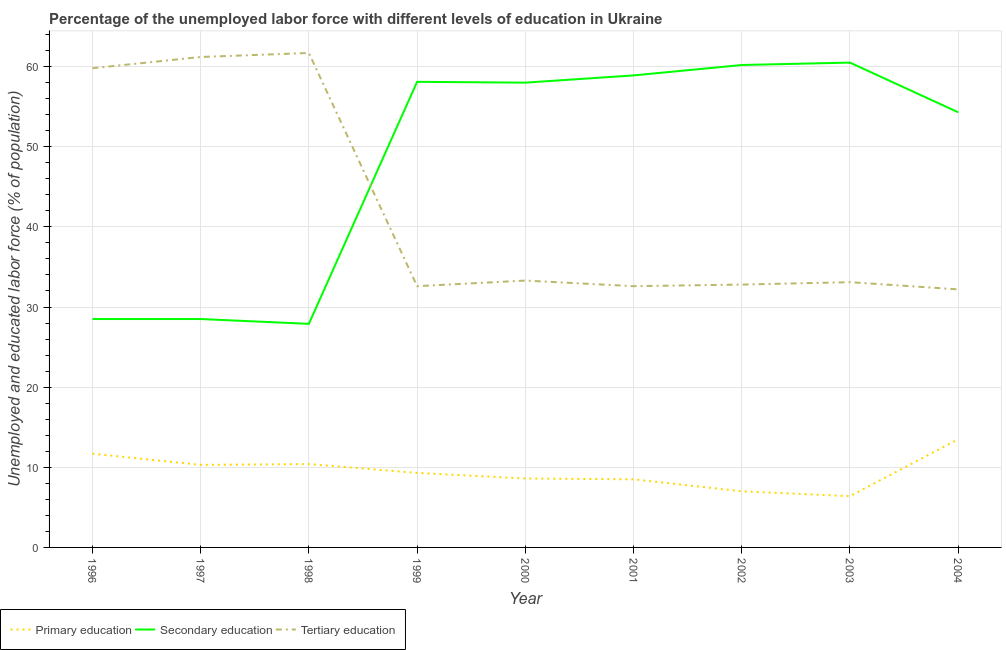Does the line corresponding to percentage of labor force who received secondary education intersect with the line corresponding to percentage of labor force who received tertiary education?
Offer a very short reply. Yes. Is the number of lines equal to the number of legend labels?
Your answer should be very brief. Yes. What is the percentage of labor force who received secondary education in 2003?
Your answer should be compact. 60.5. Across all years, what is the maximum percentage of labor force who received secondary education?
Provide a succinct answer. 60.5. Across all years, what is the minimum percentage of labor force who received secondary education?
Your answer should be very brief. 27.9. In which year was the percentage of labor force who received tertiary education maximum?
Provide a short and direct response. 1998. What is the total percentage of labor force who received secondary education in the graph?
Offer a very short reply. 434.9. What is the difference between the percentage of labor force who received primary education in 1999 and that in 2003?
Give a very brief answer. 2.9. What is the difference between the percentage of labor force who received primary education in 1998 and the percentage of labor force who received tertiary education in 2000?
Your answer should be compact. -22.9. What is the average percentage of labor force who received tertiary education per year?
Keep it short and to the point. 42.14. In the year 2004, what is the difference between the percentage of labor force who received primary education and percentage of labor force who received secondary education?
Your answer should be compact. -40.8. In how many years, is the percentage of labor force who received primary education greater than 26 %?
Make the answer very short. 0. What is the ratio of the percentage of labor force who received secondary education in 1999 to that in 2001?
Make the answer very short. 0.99. Is the percentage of labor force who received primary education in 2001 less than that in 2002?
Your answer should be very brief. No. What is the difference between the highest and the second highest percentage of labor force who received primary education?
Your answer should be compact. 1.8. What is the difference between the highest and the lowest percentage of labor force who received tertiary education?
Offer a very short reply. 29.5. In how many years, is the percentage of labor force who received primary education greater than the average percentage of labor force who received primary education taken over all years?
Provide a short and direct response. 4. Is the sum of the percentage of labor force who received primary education in 1998 and 2004 greater than the maximum percentage of labor force who received secondary education across all years?
Provide a succinct answer. No. Does the percentage of labor force who received tertiary education monotonically increase over the years?
Provide a short and direct response. No. Is the percentage of labor force who received secondary education strictly greater than the percentage of labor force who received tertiary education over the years?
Provide a succinct answer. No. What is the difference between two consecutive major ticks on the Y-axis?
Keep it short and to the point. 10. Are the values on the major ticks of Y-axis written in scientific E-notation?
Keep it short and to the point. No. Does the graph contain any zero values?
Your answer should be very brief. No. Does the graph contain grids?
Make the answer very short. Yes. What is the title of the graph?
Ensure brevity in your answer.  Percentage of the unemployed labor force with different levels of education in Ukraine. Does "Transport equipments" appear as one of the legend labels in the graph?
Keep it short and to the point. No. What is the label or title of the X-axis?
Provide a short and direct response. Year. What is the label or title of the Y-axis?
Your answer should be very brief. Unemployed and educated labor force (% of population). What is the Unemployed and educated labor force (% of population) in Primary education in 1996?
Your answer should be very brief. 11.7. What is the Unemployed and educated labor force (% of population) in Tertiary education in 1996?
Give a very brief answer. 59.8. What is the Unemployed and educated labor force (% of population) in Primary education in 1997?
Provide a succinct answer. 10.3. What is the Unemployed and educated labor force (% of population) of Secondary education in 1997?
Provide a succinct answer. 28.5. What is the Unemployed and educated labor force (% of population) in Tertiary education in 1997?
Make the answer very short. 61.2. What is the Unemployed and educated labor force (% of population) in Primary education in 1998?
Keep it short and to the point. 10.4. What is the Unemployed and educated labor force (% of population) in Secondary education in 1998?
Provide a short and direct response. 27.9. What is the Unemployed and educated labor force (% of population) in Tertiary education in 1998?
Provide a succinct answer. 61.7. What is the Unemployed and educated labor force (% of population) of Primary education in 1999?
Ensure brevity in your answer.  9.3. What is the Unemployed and educated labor force (% of population) of Secondary education in 1999?
Your answer should be very brief. 58.1. What is the Unemployed and educated labor force (% of population) in Tertiary education in 1999?
Provide a succinct answer. 32.6. What is the Unemployed and educated labor force (% of population) in Primary education in 2000?
Your response must be concise. 8.6. What is the Unemployed and educated labor force (% of population) of Secondary education in 2000?
Your answer should be very brief. 58. What is the Unemployed and educated labor force (% of population) in Tertiary education in 2000?
Provide a succinct answer. 33.3. What is the Unemployed and educated labor force (% of population) in Primary education in 2001?
Offer a very short reply. 8.5. What is the Unemployed and educated labor force (% of population) of Secondary education in 2001?
Offer a terse response. 58.9. What is the Unemployed and educated labor force (% of population) in Tertiary education in 2001?
Keep it short and to the point. 32.6. What is the Unemployed and educated labor force (% of population) in Primary education in 2002?
Make the answer very short. 7. What is the Unemployed and educated labor force (% of population) in Secondary education in 2002?
Ensure brevity in your answer.  60.2. What is the Unemployed and educated labor force (% of population) of Tertiary education in 2002?
Your answer should be compact. 32.8. What is the Unemployed and educated labor force (% of population) of Primary education in 2003?
Make the answer very short. 6.4. What is the Unemployed and educated labor force (% of population) of Secondary education in 2003?
Provide a short and direct response. 60.5. What is the Unemployed and educated labor force (% of population) in Tertiary education in 2003?
Your response must be concise. 33.1. What is the Unemployed and educated labor force (% of population) of Primary education in 2004?
Give a very brief answer. 13.5. What is the Unemployed and educated labor force (% of population) in Secondary education in 2004?
Keep it short and to the point. 54.3. What is the Unemployed and educated labor force (% of population) of Tertiary education in 2004?
Your answer should be compact. 32.2. Across all years, what is the maximum Unemployed and educated labor force (% of population) of Primary education?
Your answer should be compact. 13.5. Across all years, what is the maximum Unemployed and educated labor force (% of population) in Secondary education?
Ensure brevity in your answer.  60.5. Across all years, what is the maximum Unemployed and educated labor force (% of population) of Tertiary education?
Offer a very short reply. 61.7. Across all years, what is the minimum Unemployed and educated labor force (% of population) of Primary education?
Provide a succinct answer. 6.4. Across all years, what is the minimum Unemployed and educated labor force (% of population) of Secondary education?
Provide a short and direct response. 27.9. Across all years, what is the minimum Unemployed and educated labor force (% of population) in Tertiary education?
Your answer should be very brief. 32.2. What is the total Unemployed and educated labor force (% of population) in Primary education in the graph?
Give a very brief answer. 85.7. What is the total Unemployed and educated labor force (% of population) in Secondary education in the graph?
Keep it short and to the point. 434.9. What is the total Unemployed and educated labor force (% of population) of Tertiary education in the graph?
Give a very brief answer. 379.3. What is the difference between the Unemployed and educated labor force (% of population) in Primary education in 1996 and that in 1997?
Your response must be concise. 1.4. What is the difference between the Unemployed and educated labor force (% of population) in Tertiary education in 1996 and that in 1997?
Provide a succinct answer. -1.4. What is the difference between the Unemployed and educated labor force (% of population) in Tertiary education in 1996 and that in 1998?
Your answer should be compact. -1.9. What is the difference between the Unemployed and educated labor force (% of population) in Primary education in 1996 and that in 1999?
Offer a terse response. 2.4. What is the difference between the Unemployed and educated labor force (% of population) in Secondary education in 1996 and that in 1999?
Make the answer very short. -29.6. What is the difference between the Unemployed and educated labor force (% of population) of Tertiary education in 1996 and that in 1999?
Ensure brevity in your answer.  27.2. What is the difference between the Unemployed and educated labor force (% of population) of Primary education in 1996 and that in 2000?
Provide a short and direct response. 3.1. What is the difference between the Unemployed and educated labor force (% of population) in Secondary education in 1996 and that in 2000?
Offer a terse response. -29.5. What is the difference between the Unemployed and educated labor force (% of population) of Tertiary education in 1996 and that in 2000?
Provide a short and direct response. 26.5. What is the difference between the Unemployed and educated labor force (% of population) of Primary education in 1996 and that in 2001?
Your answer should be compact. 3.2. What is the difference between the Unemployed and educated labor force (% of population) in Secondary education in 1996 and that in 2001?
Make the answer very short. -30.4. What is the difference between the Unemployed and educated labor force (% of population) in Tertiary education in 1996 and that in 2001?
Provide a short and direct response. 27.2. What is the difference between the Unemployed and educated labor force (% of population) of Primary education in 1996 and that in 2002?
Your answer should be very brief. 4.7. What is the difference between the Unemployed and educated labor force (% of population) of Secondary education in 1996 and that in 2002?
Provide a succinct answer. -31.7. What is the difference between the Unemployed and educated labor force (% of population) in Tertiary education in 1996 and that in 2002?
Give a very brief answer. 27. What is the difference between the Unemployed and educated labor force (% of population) in Secondary education in 1996 and that in 2003?
Keep it short and to the point. -32. What is the difference between the Unemployed and educated labor force (% of population) of Tertiary education in 1996 and that in 2003?
Ensure brevity in your answer.  26.7. What is the difference between the Unemployed and educated labor force (% of population) of Primary education in 1996 and that in 2004?
Ensure brevity in your answer.  -1.8. What is the difference between the Unemployed and educated labor force (% of population) of Secondary education in 1996 and that in 2004?
Your response must be concise. -25.8. What is the difference between the Unemployed and educated labor force (% of population) of Tertiary education in 1996 and that in 2004?
Ensure brevity in your answer.  27.6. What is the difference between the Unemployed and educated labor force (% of population) of Tertiary education in 1997 and that in 1998?
Offer a terse response. -0.5. What is the difference between the Unemployed and educated labor force (% of population) of Secondary education in 1997 and that in 1999?
Offer a very short reply. -29.6. What is the difference between the Unemployed and educated labor force (% of population) of Tertiary education in 1997 and that in 1999?
Your answer should be very brief. 28.6. What is the difference between the Unemployed and educated labor force (% of population) in Secondary education in 1997 and that in 2000?
Your answer should be very brief. -29.5. What is the difference between the Unemployed and educated labor force (% of population) of Tertiary education in 1997 and that in 2000?
Make the answer very short. 27.9. What is the difference between the Unemployed and educated labor force (% of population) of Primary education in 1997 and that in 2001?
Provide a short and direct response. 1.8. What is the difference between the Unemployed and educated labor force (% of population) of Secondary education in 1997 and that in 2001?
Offer a very short reply. -30.4. What is the difference between the Unemployed and educated labor force (% of population) of Tertiary education in 1997 and that in 2001?
Offer a very short reply. 28.6. What is the difference between the Unemployed and educated labor force (% of population) in Secondary education in 1997 and that in 2002?
Ensure brevity in your answer.  -31.7. What is the difference between the Unemployed and educated labor force (% of population) in Tertiary education in 1997 and that in 2002?
Your answer should be very brief. 28.4. What is the difference between the Unemployed and educated labor force (% of population) in Secondary education in 1997 and that in 2003?
Offer a terse response. -32. What is the difference between the Unemployed and educated labor force (% of population) of Tertiary education in 1997 and that in 2003?
Your response must be concise. 28.1. What is the difference between the Unemployed and educated labor force (% of population) in Secondary education in 1997 and that in 2004?
Provide a short and direct response. -25.8. What is the difference between the Unemployed and educated labor force (% of population) of Secondary education in 1998 and that in 1999?
Make the answer very short. -30.2. What is the difference between the Unemployed and educated labor force (% of population) of Tertiary education in 1998 and that in 1999?
Offer a very short reply. 29.1. What is the difference between the Unemployed and educated labor force (% of population) in Secondary education in 1998 and that in 2000?
Keep it short and to the point. -30.1. What is the difference between the Unemployed and educated labor force (% of population) in Tertiary education in 1998 and that in 2000?
Provide a succinct answer. 28.4. What is the difference between the Unemployed and educated labor force (% of population) of Primary education in 1998 and that in 2001?
Your answer should be very brief. 1.9. What is the difference between the Unemployed and educated labor force (% of population) in Secondary education in 1998 and that in 2001?
Provide a succinct answer. -31. What is the difference between the Unemployed and educated labor force (% of population) in Tertiary education in 1998 and that in 2001?
Your answer should be compact. 29.1. What is the difference between the Unemployed and educated labor force (% of population) in Secondary education in 1998 and that in 2002?
Offer a very short reply. -32.3. What is the difference between the Unemployed and educated labor force (% of population) in Tertiary education in 1998 and that in 2002?
Provide a succinct answer. 28.9. What is the difference between the Unemployed and educated labor force (% of population) of Primary education in 1998 and that in 2003?
Ensure brevity in your answer.  4. What is the difference between the Unemployed and educated labor force (% of population) of Secondary education in 1998 and that in 2003?
Your response must be concise. -32.6. What is the difference between the Unemployed and educated labor force (% of population) of Tertiary education in 1998 and that in 2003?
Make the answer very short. 28.6. What is the difference between the Unemployed and educated labor force (% of population) of Primary education in 1998 and that in 2004?
Provide a short and direct response. -3.1. What is the difference between the Unemployed and educated labor force (% of population) of Secondary education in 1998 and that in 2004?
Give a very brief answer. -26.4. What is the difference between the Unemployed and educated labor force (% of population) of Tertiary education in 1998 and that in 2004?
Provide a succinct answer. 29.5. What is the difference between the Unemployed and educated labor force (% of population) in Secondary education in 1999 and that in 2000?
Keep it short and to the point. 0.1. What is the difference between the Unemployed and educated labor force (% of population) of Tertiary education in 1999 and that in 2000?
Your answer should be very brief. -0.7. What is the difference between the Unemployed and educated labor force (% of population) in Primary education in 1999 and that in 2001?
Offer a very short reply. 0.8. What is the difference between the Unemployed and educated labor force (% of population) in Primary education in 1999 and that in 2002?
Your answer should be compact. 2.3. What is the difference between the Unemployed and educated labor force (% of population) in Secondary education in 1999 and that in 2002?
Provide a succinct answer. -2.1. What is the difference between the Unemployed and educated labor force (% of population) in Primary education in 1999 and that in 2003?
Make the answer very short. 2.9. What is the difference between the Unemployed and educated labor force (% of population) of Tertiary education in 1999 and that in 2003?
Keep it short and to the point. -0.5. What is the difference between the Unemployed and educated labor force (% of population) in Primary education in 2000 and that in 2001?
Provide a succinct answer. 0.1. What is the difference between the Unemployed and educated labor force (% of population) of Tertiary education in 2000 and that in 2001?
Offer a very short reply. 0.7. What is the difference between the Unemployed and educated labor force (% of population) in Primary education in 2000 and that in 2002?
Offer a very short reply. 1.6. What is the difference between the Unemployed and educated labor force (% of population) in Primary education in 2000 and that in 2003?
Provide a short and direct response. 2.2. What is the difference between the Unemployed and educated labor force (% of population) in Secondary education in 2000 and that in 2003?
Give a very brief answer. -2.5. What is the difference between the Unemployed and educated labor force (% of population) of Primary education in 2000 and that in 2004?
Offer a terse response. -4.9. What is the difference between the Unemployed and educated labor force (% of population) in Secondary education in 2000 and that in 2004?
Your response must be concise. 3.7. What is the difference between the Unemployed and educated labor force (% of population) in Tertiary education in 2000 and that in 2004?
Your answer should be compact. 1.1. What is the difference between the Unemployed and educated labor force (% of population) of Primary education in 2001 and that in 2002?
Offer a very short reply. 1.5. What is the difference between the Unemployed and educated labor force (% of population) in Secondary education in 2001 and that in 2004?
Offer a very short reply. 4.6. What is the difference between the Unemployed and educated labor force (% of population) of Tertiary education in 2001 and that in 2004?
Provide a succinct answer. 0.4. What is the difference between the Unemployed and educated labor force (% of population) of Primary education in 2002 and that in 2003?
Keep it short and to the point. 0.6. What is the difference between the Unemployed and educated labor force (% of population) of Primary education in 2002 and that in 2004?
Keep it short and to the point. -6.5. What is the difference between the Unemployed and educated labor force (% of population) in Secondary education in 2002 and that in 2004?
Your answer should be very brief. 5.9. What is the difference between the Unemployed and educated labor force (% of population) of Tertiary education in 2002 and that in 2004?
Offer a terse response. 0.6. What is the difference between the Unemployed and educated labor force (% of population) of Tertiary education in 2003 and that in 2004?
Your answer should be very brief. 0.9. What is the difference between the Unemployed and educated labor force (% of population) of Primary education in 1996 and the Unemployed and educated labor force (% of population) of Secondary education in 1997?
Make the answer very short. -16.8. What is the difference between the Unemployed and educated labor force (% of population) in Primary education in 1996 and the Unemployed and educated labor force (% of population) in Tertiary education in 1997?
Offer a terse response. -49.5. What is the difference between the Unemployed and educated labor force (% of population) in Secondary education in 1996 and the Unemployed and educated labor force (% of population) in Tertiary education in 1997?
Your answer should be very brief. -32.7. What is the difference between the Unemployed and educated labor force (% of population) of Primary education in 1996 and the Unemployed and educated labor force (% of population) of Secondary education in 1998?
Ensure brevity in your answer.  -16.2. What is the difference between the Unemployed and educated labor force (% of population) of Secondary education in 1996 and the Unemployed and educated labor force (% of population) of Tertiary education in 1998?
Provide a short and direct response. -33.2. What is the difference between the Unemployed and educated labor force (% of population) of Primary education in 1996 and the Unemployed and educated labor force (% of population) of Secondary education in 1999?
Provide a succinct answer. -46.4. What is the difference between the Unemployed and educated labor force (% of population) in Primary education in 1996 and the Unemployed and educated labor force (% of population) in Tertiary education in 1999?
Ensure brevity in your answer.  -20.9. What is the difference between the Unemployed and educated labor force (% of population) in Primary education in 1996 and the Unemployed and educated labor force (% of population) in Secondary education in 2000?
Ensure brevity in your answer.  -46.3. What is the difference between the Unemployed and educated labor force (% of population) in Primary education in 1996 and the Unemployed and educated labor force (% of population) in Tertiary education in 2000?
Your response must be concise. -21.6. What is the difference between the Unemployed and educated labor force (% of population) of Primary education in 1996 and the Unemployed and educated labor force (% of population) of Secondary education in 2001?
Give a very brief answer. -47.2. What is the difference between the Unemployed and educated labor force (% of population) of Primary education in 1996 and the Unemployed and educated labor force (% of population) of Tertiary education in 2001?
Provide a succinct answer. -20.9. What is the difference between the Unemployed and educated labor force (% of population) of Secondary education in 1996 and the Unemployed and educated labor force (% of population) of Tertiary education in 2001?
Provide a short and direct response. -4.1. What is the difference between the Unemployed and educated labor force (% of population) of Primary education in 1996 and the Unemployed and educated labor force (% of population) of Secondary education in 2002?
Ensure brevity in your answer.  -48.5. What is the difference between the Unemployed and educated labor force (% of population) of Primary education in 1996 and the Unemployed and educated labor force (% of population) of Tertiary education in 2002?
Make the answer very short. -21.1. What is the difference between the Unemployed and educated labor force (% of population) of Secondary education in 1996 and the Unemployed and educated labor force (% of population) of Tertiary education in 2002?
Ensure brevity in your answer.  -4.3. What is the difference between the Unemployed and educated labor force (% of population) of Primary education in 1996 and the Unemployed and educated labor force (% of population) of Secondary education in 2003?
Offer a very short reply. -48.8. What is the difference between the Unemployed and educated labor force (% of population) in Primary education in 1996 and the Unemployed and educated labor force (% of population) in Tertiary education in 2003?
Keep it short and to the point. -21.4. What is the difference between the Unemployed and educated labor force (% of population) of Secondary education in 1996 and the Unemployed and educated labor force (% of population) of Tertiary education in 2003?
Provide a short and direct response. -4.6. What is the difference between the Unemployed and educated labor force (% of population) in Primary education in 1996 and the Unemployed and educated labor force (% of population) in Secondary education in 2004?
Provide a succinct answer. -42.6. What is the difference between the Unemployed and educated labor force (% of population) in Primary education in 1996 and the Unemployed and educated labor force (% of population) in Tertiary education in 2004?
Offer a very short reply. -20.5. What is the difference between the Unemployed and educated labor force (% of population) of Secondary education in 1996 and the Unemployed and educated labor force (% of population) of Tertiary education in 2004?
Provide a succinct answer. -3.7. What is the difference between the Unemployed and educated labor force (% of population) of Primary education in 1997 and the Unemployed and educated labor force (% of population) of Secondary education in 1998?
Offer a very short reply. -17.6. What is the difference between the Unemployed and educated labor force (% of population) of Primary education in 1997 and the Unemployed and educated labor force (% of population) of Tertiary education in 1998?
Provide a succinct answer. -51.4. What is the difference between the Unemployed and educated labor force (% of population) of Secondary education in 1997 and the Unemployed and educated labor force (% of population) of Tertiary education in 1998?
Offer a terse response. -33.2. What is the difference between the Unemployed and educated labor force (% of population) of Primary education in 1997 and the Unemployed and educated labor force (% of population) of Secondary education in 1999?
Provide a short and direct response. -47.8. What is the difference between the Unemployed and educated labor force (% of population) of Primary education in 1997 and the Unemployed and educated labor force (% of population) of Tertiary education in 1999?
Make the answer very short. -22.3. What is the difference between the Unemployed and educated labor force (% of population) of Primary education in 1997 and the Unemployed and educated labor force (% of population) of Secondary education in 2000?
Ensure brevity in your answer.  -47.7. What is the difference between the Unemployed and educated labor force (% of population) in Secondary education in 1997 and the Unemployed and educated labor force (% of population) in Tertiary education in 2000?
Provide a short and direct response. -4.8. What is the difference between the Unemployed and educated labor force (% of population) of Primary education in 1997 and the Unemployed and educated labor force (% of population) of Secondary education in 2001?
Offer a terse response. -48.6. What is the difference between the Unemployed and educated labor force (% of population) of Primary education in 1997 and the Unemployed and educated labor force (% of population) of Tertiary education in 2001?
Ensure brevity in your answer.  -22.3. What is the difference between the Unemployed and educated labor force (% of population) of Primary education in 1997 and the Unemployed and educated labor force (% of population) of Secondary education in 2002?
Offer a very short reply. -49.9. What is the difference between the Unemployed and educated labor force (% of population) in Primary education in 1997 and the Unemployed and educated labor force (% of population) in Tertiary education in 2002?
Your answer should be very brief. -22.5. What is the difference between the Unemployed and educated labor force (% of population) of Primary education in 1997 and the Unemployed and educated labor force (% of population) of Secondary education in 2003?
Offer a terse response. -50.2. What is the difference between the Unemployed and educated labor force (% of population) of Primary education in 1997 and the Unemployed and educated labor force (% of population) of Tertiary education in 2003?
Offer a terse response. -22.8. What is the difference between the Unemployed and educated labor force (% of population) of Secondary education in 1997 and the Unemployed and educated labor force (% of population) of Tertiary education in 2003?
Keep it short and to the point. -4.6. What is the difference between the Unemployed and educated labor force (% of population) of Primary education in 1997 and the Unemployed and educated labor force (% of population) of Secondary education in 2004?
Your response must be concise. -44. What is the difference between the Unemployed and educated labor force (% of population) of Primary education in 1997 and the Unemployed and educated labor force (% of population) of Tertiary education in 2004?
Give a very brief answer. -21.9. What is the difference between the Unemployed and educated labor force (% of population) in Secondary education in 1997 and the Unemployed and educated labor force (% of population) in Tertiary education in 2004?
Offer a very short reply. -3.7. What is the difference between the Unemployed and educated labor force (% of population) of Primary education in 1998 and the Unemployed and educated labor force (% of population) of Secondary education in 1999?
Keep it short and to the point. -47.7. What is the difference between the Unemployed and educated labor force (% of population) of Primary education in 1998 and the Unemployed and educated labor force (% of population) of Tertiary education in 1999?
Keep it short and to the point. -22.2. What is the difference between the Unemployed and educated labor force (% of population) in Secondary education in 1998 and the Unemployed and educated labor force (% of population) in Tertiary education in 1999?
Ensure brevity in your answer.  -4.7. What is the difference between the Unemployed and educated labor force (% of population) in Primary education in 1998 and the Unemployed and educated labor force (% of population) in Secondary education in 2000?
Offer a very short reply. -47.6. What is the difference between the Unemployed and educated labor force (% of population) in Primary education in 1998 and the Unemployed and educated labor force (% of population) in Tertiary education in 2000?
Give a very brief answer. -22.9. What is the difference between the Unemployed and educated labor force (% of population) in Primary education in 1998 and the Unemployed and educated labor force (% of population) in Secondary education in 2001?
Offer a terse response. -48.5. What is the difference between the Unemployed and educated labor force (% of population) in Primary education in 1998 and the Unemployed and educated labor force (% of population) in Tertiary education in 2001?
Your answer should be very brief. -22.2. What is the difference between the Unemployed and educated labor force (% of population) of Primary education in 1998 and the Unemployed and educated labor force (% of population) of Secondary education in 2002?
Provide a short and direct response. -49.8. What is the difference between the Unemployed and educated labor force (% of population) of Primary education in 1998 and the Unemployed and educated labor force (% of population) of Tertiary education in 2002?
Provide a short and direct response. -22.4. What is the difference between the Unemployed and educated labor force (% of population) in Secondary education in 1998 and the Unemployed and educated labor force (% of population) in Tertiary education in 2002?
Your answer should be compact. -4.9. What is the difference between the Unemployed and educated labor force (% of population) in Primary education in 1998 and the Unemployed and educated labor force (% of population) in Secondary education in 2003?
Provide a short and direct response. -50.1. What is the difference between the Unemployed and educated labor force (% of population) of Primary education in 1998 and the Unemployed and educated labor force (% of population) of Tertiary education in 2003?
Offer a very short reply. -22.7. What is the difference between the Unemployed and educated labor force (% of population) in Secondary education in 1998 and the Unemployed and educated labor force (% of population) in Tertiary education in 2003?
Offer a terse response. -5.2. What is the difference between the Unemployed and educated labor force (% of population) of Primary education in 1998 and the Unemployed and educated labor force (% of population) of Secondary education in 2004?
Make the answer very short. -43.9. What is the difference between the Unemployed and educated labor force (% of population) of Primary education in 1998 and the Unemployed and educated labor force (% of population) of Tertiary education in 2004?
Ensure brevity in your answer.  -21.8. What is the difference between the Unemployed and educated labor force (% of population) in Secondary education in 1998 and the Unemployed and educated labor force (% of population) in Tertiary education in 2004?
Your answer should be very brief. -4.3. What is the difference between the Unemployed and educated labor force (% of population) of Primary education in 1999 and the Unemployed and educated labor force (% of population) of Secondary education in 2000?
Your answer should be very brief. -48.7. What is the difference between the Unemployed and educated labor force (% of population) of Secondary education in 1999 and the Unemployed and educated labor force (% of population) of Tertiary education in 2000?
Give a very brief answer. 24.8. What is the difference between the Unemployed and educated labor force (% of population) of Primary education in 1999 and the Unemployed and educated labor force (% of population) of Secondary education in 2001?
Provide a succinct answer. -49.6. What is the difference between the Unemployed and educated labor force (% of population) of Primary education in 1999 and the Unemployed and educated labor force (% of population) of Tertiary education in 2001?
Offer a terse response. -23.3. What is the difference between the Unemployed and educated labor force (% of population) of Primary education in 1999 and the Unemployed and educated labor force (% of population) of Secondary education in 2002?
Your answer should be very brief. -50.9. What is the difference between the Unemployed and educated labor force (% of population) of Primary education in 1999 and the Unemployed and educated labor force (% of population) of Tertiary education in 2002?
Give a very brief answer. -23.5. What is the difference between the Unemployed and educated labor force (% of population) in Secondary education in 1999 and the Unemployed and educated labor force (% of population) in Tertiary education in 2002?
Your answer should be compact. 25.3. What is the difference between the Unemployed and educated labor force (% of population) of Primary education in 1999 and the Unemployed and educated labor force (% of population) of Secondary education in 2003?
Make the answer very short. -51.2. What is the difference between the Unemployed and educated labor force (% of population) in Primary education in 1999 and the Unemployed and educated labor force (% of population) in Tertiary education in 2003?
Provide a short and direct response. -23.8. What is the difference between the Unemployed and educated labor force (% of population) in Secondary education in 1999 and the Unemployed and educated labor force (% of population) in Tertiary education in 2003?
Ensure brevity in your answer.  25. What is the difference between the Unemployed and educated labor force (% of population) of Primary education in 1999 and the Unemployed and educated labor force (% of population) of Secondary education in 2004?
Ensure brevity in your answer.  -45. What is the difference between the Unemployed and educated labor force (% of population) of Primary education in 1999 and the Unemployed and educated labor force (% of population) of Tertiary education in 2004?
Offer a terse response. -22.9. What is the difference between the Unemployed and educated labor force (% of population) in Secondary education in 1999 and the Unemployed and educated labor force (% of population) in Tertiary education in 2004?
Ensure brevity in your answer.  25.9. What is the difference between the Unemployed and educated labor force (% of population) in Primary education in 2000 and the Unemployed and educated labor force (% of population) in Secondary education in 2001?
Make the answer very short. -50.3. What is the difference between the Unemployed and educated labor force (% of population) of Secondary education in 2000 and the Unemployed and educated labor force (% of population) of Tertiary education in 2001?
Give a very brief answer. 25.4. What is the difference between the Unemployed and educated labor force (% of population) of Primary education in 2000 and the Unemployed and educated labor force (% of population) of Secondary education in 2002?
Offer a very short reply. -51.6. What is the difference between the Unemployed and educated labor force (% of population) in Primary education in 2000 and the Unemployed and educated labor force (% of population) in Tertiary education in 2002?
Keep it short and to the point. -24.2. What is the difference between the Unemployed and educated labor force (% of population) in Secondary education in 2000 and the Unemployed and educated labor force (% of population) in Tertiary education in 2002?
Your answer should be very brief. 25.2. What is the difference between the Unemployed and educated labor force (% of population) of Primary education in 2000 and the Unemployed and educated labor force (% of population) of Secondary education in 2003?
Your response must be concise. -51.9. What is the difference between the Unemployed and educated labor force (% of population) of Primary education in 2000 and the Unemployed and educated labor force (% of population) of Tertiary education in 2003?
Make the answer very short. -24.5. What is the difference between the Unemployed and educated labor force (% of population) in Secondary education in 2000 and the Unemployed and educated labor force (% of population) in Tertiary education in 2003?
Offer a very short reply. 24.9. What is the difference between the Unemployed and educated labor force (% of population) in Primary education in 2000 and the Unemployed and educated labor force (% of population) in Secondary education in 2004?
Give a very brief answer. -45.7. What is the difference between the Unemployed and educated labor force (% of population) in Primary education in 2000 and the Unemployed and educated labor force (% of population) in Tertiary education in 2004?
Ensure brevity in your answer.  -23.6. What is the difference between the Unemployed and educated labor force (% of population) in Secondary education in 2000 and the Unemployed and educated labor force (% of population) in Tertiary education in 2004?
Make the answer very short. 25.8. What is the difference between the Unemployed and educated labor force (% of population) of Primary education in 2001 and the Unemployed and educated labor force (% of population) of Secondary education in 2002?
Offer a very short reply. -51.7. What is the difference between the Unemployed and educated labor force (% of population) of Primary education in 2001 and the Unemployed and educated labor force (% of population) of Tertiary education in 2002?
Give a very brief answer. -24.3. What is the difference between the Unemployed and educated labor force (% of population) of Secondary education in 2001 and the Unemployed and educated labor force (% of population) of Tertiary education in 2002?
Make the answer very short. 26.1. What is the difference between the Unemployed and educated labor force (% of population) of Primary education in 2001 and the Unemployed and educated labor force (% of population) of Secondary education in 2003?
Offer a very short reply. -52. What is the difference between the Unemployed and educated labor force (% of population) of Primary education in 2001 and the Unemployed and educated labor force (% of population) of Tertiary education in 2003?
Give a very brief answer. -24.6. What is the difference between the Unemployed and educated labor force (% of population) in Secondary education in 2001 and the Unemployed and educated labor force (% of population) in Tertiary education in 2003?
Your response must be concise. 25.8. What is the difference between the Unemployed and educated labor force (% of population) of Primary education in 2001 and the Unemployed and educated labor force (% of population) of Secondary education in 2004?
Give a very brief answer. -45.8. What is the difference between the Unemployed and educated labor force (% of population) in Primary education in 2001 and the Unemployed and educated labor force (% of population) in Tertiary education in 2004?
Provide a short and direct response. -23.7. What is the difference between the Unemployed and educated labor force (% of population) in Secondary education in 2001 and the Unemployed and educated labor force (% of population) in Tertiary education in 2004?
Ensure brevity in your answer.  26.7. What is the difference between the Unemployed and educated labor force (% of population) of Primary education in 2002 and the Unemployed and educated labor force (% of population) of Secondary education in 2003?
Keep it short and to the point. -53.5. What is the difference between the Unemployed and educated labor force (% of population) in Primary education in 2002 and the Unemployed and educated labor force (% of population) in Tertiary education in 2003?
Provide a succinct answer. -26.1. What is the difference between the Unemployed and educated labor force (% of population) in Secondary education in 2002 and the Unemployed and educated labor force (% of population) in Tertiary education in 2003?
Provide a succinct answer. 27.1. What is the difference between the Unemployed and educated labor force (% of population) in Primary education in 2002 and the Unemployed and educated labor force (% of population) in Secondary education in 2004?
Offer a terse response. -47.3. What is the difference between the Unemployed and educated labor force (% of population) of Primary education in 2002 and the Unemployed and educated labor force (% of population) of Tertiary education in 2004?
Your response must be concise. -25.2. What is the difference between the Unemployed and educated labor force (% of population) of Primary education in 2003 and the Unemployed and educated labor force (% of population) of Secondary education in 2004?
Offer a very short reply. -47.9. What is the difference between the Unemployed and educated labor force (% of population) of Primary education in 2003 and the Unemployed and educated labor force (% of population) of Tertiary education in 2004?
Provide a short and direct response. -25.8. What is the difference between the Unemployed and educated labor force (% of population) in Secondary education in 2003 and the Unemployed and educated labor force (% of population) in Tertiary education in 2004?
Your response must be concise. 28.3. What is the average Unemployed and educated labor force (% of population) in Primary education per year?
Offer a terse response. 9.52. What is the average Unemployed and educated labor force (% of population) in Secondary education per year?
Provide a succinct answer. 48.32. What is the average Unemployed and educated labor force (% of population) of Tertiary education per year?
Offer a very short reply. 42.14. In the year 1996, what is the difference between the Unemployed and educated labor force (% of population) in Primary education and Unemployed and educated labor force (% of population) in Secondary education?
Provide a succinct answer. -16.8. In the year 1996, what is the difference between the Unemployed and educated labor force (% of population) in Primary education and Unemployed and educated labor force (% of population) in Tertiary education?
Keep it short and to the point. -48.1. In the year 1996, what is the difference between the Unemployed and educated labor force (% of population) in Secondary education and Unemployed and educated labor force (% of population) in Tertiary education?
Keep it short and to the point. -31.3. In the year 1997, what is the difference between the Unemployed and educated labor force (% of population) in Primary education and Unemployed and educated labor force (% of population) in Secondary education?
Your response must be concise. -18.2. In the year 1997, what is the difference between the Unemployed and educated labor force (% of population) in Primary education and Unemployed and educated labor force (% of population) in Tertiary education?
Offer a very short reply. -50.9. In the year 1997, what is the difference between the Unemployed and educated labor force (% of population) in Secondary education and Unemployed and educated labor force (% of population) in Tertiary education?
Keep it short and to the point. -32.7. In the year 1998, what is the difference between the Unemployed and educated labor force (% of population) in Primary education and Unemployed and educated labor force (% of population) in Secondary education?
Your answer should be very brief. -17.5. In the year 1998, what is the difference between the Unemployed and educated labor force (% of population) of Primary education and Unemployed and educated labor force (% of population) of Tertiary education?
Offer a very short reply. -51.3. In the year 1998, what is the difference between the Unemployed and educated labor force (% of population) in Secondary education and Unemployed and educated labor force (% of population) in Tertiary education?
Offer a very short reply. -33.8. In the year 1999, what is the difference between the Unemployed and educated labor force (% of population) in Primary education and Unemployed and educated labor force (% of population) in Secondary education?
Make the answer very short. -48.8. In the year 1999, what is the difference between the Unemployed and educated labor force (% of population) of Primary education and Unemployed and educated labor force (% of population) of Tertiary education?
Your answer should be very brief. -23.3. In the year 2000, what is the difference between the Unemployed and educated labor force (% of population) in Primary education and Unemployed and educated labor force (% of population) in Secondary education?
Ensure brevity in your answer.  -49.4. In the year 2000, what is the difference between the Unemployed and educated labor force (% of population) in Primary education and Unemployed and educated labor force (% of population) in Tertiary education?
Your answer should be very brief. -24.7. In the year 2000, what is the difference between the Unemployed and educated labor force (% of population) of Secondary education and Unemployed and educated labor force (% of population) of Tertiary education?
Your answer should be very brief. 24.7. In the year 2001, what is the difference between the Unemployed and educated labor force (% of population) of Primary education and Unemployed and educated labor force (% of population) of Secondary education?
Make the answer very short. -50.4. In the year 2001, what is the difference between the Unemployed and educated labor force (% of population) of Primary education and Unemployed and educated labor force (% of population) of Tertiary education?
Make the answer very short. -24.1. In the year 2001, what is the difference between the Unemployed and educated labor force (% of population) of Secondary education and Unemployed and educated labor force (% of population) of Tertiary education?
Give a very brief answer. 26.3. In the year 2002, what is the difference between the Unemployed and educated labor force (% of population) of Primary education and Unemployed and educated labor force (% of population) of Secondary education?
Offer a terse response. -53.2. In the year 2002, what is the difference between the Unemployed and educated labor force (% of population) of Primary education and Unemployed and educated labor force (% of population) of Tertiary education?
Make the answer very short. -25.8. In the year 2002, what is the difference between the Unemployed and educated labor force (% of population) of Secondary education and Unemployed and educated labor force (% of population) of Tertiary education?
Your answer should be very brief. 27.4. In the year 2003, what is the difference between the Unemployed and educated labor force (% of population) in Primary education and Unemployed and educated labor force (% of population) in Secondary education?
Your answer should be compact. -54.1. In the year 2003, what is the difference between the Unemployed and educated labor force (% of population) of Primary education and Unemployed and educated labor force (% of population) of Tertiary education?
Provide a short and direct response. -26.7. In the year 2003, what is the difference between the Unemployed and educated labor force (% of population) in Secondary education and Unemployed and educated labor force (% of population) in Tertiary education?
Your answer should be compact. 27.4. In the year 2004, what is the difference between the Unemployed and educated labor force (% of population) in Primary education and Unemployed and educated labor force (% of population) in Secondary education?
Your answer should be compact. -40.8. In the year 2004, what is the difference between the Unemployed and educated labor force (% of population) of Primary education and Unemployed and educated labor force (% of population) of Tertiary education?
Give a very brief answer. -18.7. In the year 2004, what is the difference between the Unemployed and educated labor force (% of population) of Secondary education and Unemployed and educated labor force (% of population) of Tertiary education?
Offer a terse response. 22.1. What is the ratio of the Unemployed and educated labor force (% of population) in Primary education in 1996 to that in 1997?
Your answer should be very brief. 1.14. What is the ratio of the Unemployed and educated labor force (% of population) of Tertiary education in 1996 to that in 1997?
Keep it short and to the point. 0.98. What is the ratio of the Unemployed and educated labor force (% of population) of Secondary education in 1996 to that in 1998?
Give a very brief answer. 1.02. What is the ratio of the Unemployed and educated labor force (% of population) of Tertiary education in 1996 to that in 1998?
Your answer should be very brief. 0.97. What is the ratio of the Unemployed and educated labor force (% of population) of Primary education in 1996 to that in 1999?
Your response must be concise. 1.26. What is the ratio of the Unemployed and educated labor force (% of population) of Secondary education in 1996 to that in 1999?
Ensure brevity in your answer.  0.49. What is the ratio of the Unemployed and educated labor force (% of population) in Tertiary education in 1996 to that in 1999?
Provide a short and direct response. 1.83. What is the ratio of the Unemployed and educated labor force (% of population) in Primary education in 1996 to that in 2000?
Ensure brevity in your answer.  1.36. What is the ratio of the Unemployed and educated labor force (% of population) in Secondary education in 1996 to that in 2000?
Give a very brief answer. 0.49. What is the ratio of the Unemployed and educated labor force (% of population) of Tertiary education in 1996 to that in 2000?
Offer a terse response. 1.8. What is the ratio of the Unemployed and educated labor force (% of population) in Primary education in 1996 to that in 2001?
Your answer should be very brief. 1.38. What is the ratio of the Unemployed and educated labor force (% of population) of Secondary education in 1996 to that in 2001?
Keep it short and to the point. 0.48. What is the ratio of the Unemployed and educated labor force (% of population) of Tertiary education in 1996 to that in 2001?
Offer a terse response. 1.83. What is the ratio of the Unemployed and educated labor force (% of population) of Primary education in 1996 to that in 2002?
Your answer should be compact. 1.67. What is the ratio of the Unemployed and educated labor force (% of population) of Secondary education in 1996 to that in 2002?
Offer a terse response. 0.47. What is the ratio of the Unemployed and educated labor force (% of population) of Tertiary education in 1996 to that in 2002?
Your answer should be very brief. 1.82. What is the ratio of the Unemployed and educated labor force (% of population) of Primary education in 1996 to that in 2003?
Keep it short and to the point. 1.83. What is the ratio of the Unemployed and educated labor force (% of population) in Secondary education in 1996 to that in 2003?
Provide a short and direct response. 0.47. What is the ratio of the Unemployed and educated labor force (% of population) in Tertiary education in 1996 to that in 2003?
Ensure brevity in your answer.  1.81. What is the ratio of the Unemployed and educated labor force (% of population) in Primary education in 1996 to that in 2004?
Provide a short and direct response. 0.87. What is the ratio of the Unemployed and educated labor force (% of population) in Secondary education in 1996 to that in 2004?
Make the answer very short. 0.52. What is the ratio of the Unemployed and educated labor force (% of population) in Tertiary education in 1996 to that in 2004?
Give a very brief answer. 1.86. What is the ratio of the Unemployed and educated labor force (% of population) of Primary education in 1997 to that in 1998?
Provide a succinct answer. 0.99. What is the ratio of the Unemployed and educated labor force (% of population) of Secondary education in 1997 to that in 1998?
Offer a very short reply. 1.02. What is the ratio of the Unemployed and educated labor force (% of population) of Tertiary education in 1997 to that in 1998?
Offer a very short reply. 0.99. What is the ratio of the Unemployed and educated labor force (% of population) in Primary education in 1997 to that in 1999?
Keep it short and to the point. 1.11. What is the ratio of the Unemployed and educated labor force (% of population) of Secondary education in 1997 to that in 1999?
Make the answer very short. 0.49. What is the ratio of the Unemployed and educated labor force (% of population) in Tertiary education in 1997 to that in 1999?
Ensure brevity in your answer.  1.88. What is the ratio of the Unemployed and educated labor force (% of population) in Primary education in 1997 to that in 2000?
Your response must be concise. 1.2. What is the ratio of the Unemployed and educated labor force (% of population) of Secondary education in 1997 to that in 2000?
Provide a succinct answer. 0.49. What is the ratio of the Unemployed and educated labor force (% of population) in Tertiary education in 1997 to that in 2000?
Make the answer very short. 1.84. What is the ratio of the Unemployed and educated labor force (% of population) in Primary education in 1997 to that in 2001?
Ensure brevity in your answer.  1.21. What is the ratio of the Unemployed and educated labor force (% of population) of Secondary education in 1997 to that in 2001?
Keep it short and to the point. 0.48. What is the ratio of the Unemployed and educated labor force (% of population) in Tertiary education in 1997 to that in 2001?
Your answer should be very brief. 1.88. What is the ratio of the Unemployed and educated labor force (% of population) in Primary education in 1997 to that in 2002?
Give a very brief answer. 1.47. What is the ratio of the Unemployed and educated labor force (% of population) of Secondary education in 1997 to that in 2002?
Your answer should be very brief. 0.47. What is the ratio of the Unemployed and educated labor force (% of population) of Tertiary education in 1997 to that in 2002?
Keep it short and to the point. 1.87. What is the ratio of the Unemployed and educated labor force (% of population) in Primary education in 1997 to that in 2003?
Provide a short and direct response. 1.61. What is the ratio of the Unemployed and educated labor force (% of population) of Secondary education in 1997 to that in 2003?
Provide a succinct answer. 0.47. What is the ratio of the Unemployed and educated labor force (% of population) of Tertiary education in 1997 to that in 2003?
Provide a short and direct response. 1.85. What is the ratio of the Unemployed and educated labor force (% of population) of Primary education in 1997 to that in 2004?
Offer a very short reply. 0.76. What is the ratio of the Unemployed and educated labor force (% of population) of Secondary education in 1997 to that in 2004?
Provide a short and direct response. 0.52. What is the ratio of the Unemployed and educated labor force (% of population) of Tertiary education in 1997 to that in 2004?
Your response must be concise. 1.9. What is the ratio of the Unemployed and educated labor force (% of population) of Primary education in 1998 to that in 1999?
Give a very brief answer. 1.12. What is the ratio of the Unemployed and educated labor force (% of population) of Secondary education in 1998 to that in 1999?
Make the answer very short. 0.48. What is the ratio of the Unemployed and educated labor force (% of population) in Tertiary education in 1998 to that in 1999?
Offer a terse response. 1.89. What is the ratio of the Unemployed and educated labor force (% of population) of Primary education in 1998 to that in 2000?
Make the answer very short. 1.21. What is the ratio of the Unemployed and educated labor force (% of population) in Secondary education in 1998 to that in 2000?
Provide a succinct answer. 0.48. What is the ratio of the Unemployed and educated labor force (% of population) of Tertiary education in 1998 to that in 2000?
Offer a very short reply. 1.85. What is the ratio of the Unemployed and educated labor force (% of population) of Primary education in 1998 to that in 2001?
Offer a very short reply. 1.22. What is the ratio of the Unemployed and educated labor force (% of population) of Secondary education in 1998 to that in 2001?
Make the answer very short. 0.47. What is the ratio of the Unemployed and educated labor force (% of population) in Tertiary education in 1998 to that in 2001?
Give a very brief answer. 1.89. What is the ratio of the Unemployed and educated labor force (% of population) in Primary education in 1998 to that in 2002?
Provide a succinct answer. 1.49. What is the ratio of the Unemployed and educated labor force (% of population) of Secondary education in 1998 to that in 2002?
Make the answer very short. 0.46. What is the ratio of the Unemployed and educated labor force (% of population) of Tertiary education in 1998 to that in 2002?
Offer a terse response. 1.88. What is the ratio of the Unemployed and educated labor force (% of population) in Primary education in 1998 to that in 2003?
Your answer should be compact. 1.62. What is the ratio of the Unemployed and educated labor force (% of population) in Secondary education in 1998 to that in 2003?
Make the answer very short. 0.46. What is the ratio of the Unemployed and educated labor force (% of population) of Tertiary education in 1998 to that in 2003?
Give a very brief answer. 1.86. What is the ratio of the Unemployed and educated labor force (% of population) of Primary education in 1998 to that in 2004?
Your answer should be very brief. 0.77. What is the ratio of the Unemployed and educated labor force (% of population) of Secondary education in 1998 to that in 2004?
Ensure brevity in your answer.  0.51. What is the ratio of the Unemployed and educated labor force (% of population) in Tertiary education in 1998 to that in 2004?
Your answer should be compact. 1.92. What is the ratio of the Unemployed and educated labor force (% of population) in Primary education in 1999 to that in 2000?
Your answer should be compact. 1.08. What is the ratio of the Unemployed and educated labor force (% of population) in Secondary education in 1999 to that in 2000?
Your answer should be compact. 1. What is the ratio of the Unemployed and educated labor force (% of population) in Tertiary education in 1999 to that in 2000?
Your answer should be very brief. 0.98. What is the ratio of the Unemployed and educated labor force (% of population) of Primary education in 1999 to that in 2001?
Give a very brief answer. 1.09. What is the ratio of the Unemployed and educated labor force (% of population) of Secondary education in 1999 to that in 2001?
Your answer should be very brief. 0.99. What is the ratio of the Unemployed and educated labor force (% of population) of Tertiary education in 1999 to that in 2001?
Ensure brevity in your answer.  1. What is the ratio of the Unemployed and educated labor force (% of population) in Primary education in 1999 to that in 2002?
Provide a short and direct response. 1.33. What is the ratio of the Unemployed and educated labor force (% of population) in Secondary education in 1999 to that in 2002?
Provide a succinct answer. 0.97. What is the ratio of the Unemployed and educated labor force (% of population) in Tertiary education in 1999 to that in 2002?
Provide a short and direct response. 0.99. What is the ratio of the Unemployed and educated labor force (% of population) in Primary education in 1999 to that in 2003?
Keep it short and to the point. 1.45. What is the ratio of the Unemployed and educated labor force (% of population) in Secondary education in 1999 to that in 2003?
Provide a short and direct response. 0.96. What is the ratio of the Unemployed and educated labor force (% of population) of Tertiary education in 1999 to that in 2003?
Offer a very short reply. 0.98. What is the ratio of the Unemployed and educated labor force (% of population) of Primary education in 1999 to that in 2004?
Provide a short and direct response. 0.69. What is the ratio of the Unemployed and educated labor force (% of population) of Secondary education in 1999 to that in 2004?
Your response must be concise. 1.07. What is the ratio of the Unemployed and educated labor force (% of population) of Tertiary education in 1999 to that in 2004?
Ensure brevity in your answer.  1.01. What is the ratio of the Unemployed and educated labor force (% of population) in Primary education in 2000 to that in 2001?
Your response must be concise. 1.01. What is the ratio of the Unemployed and educated labor force (% of population) of Secondary education in 2000 to that in 2001?
Offer a very short reply. 0.98. What is the ratio of the Unemployed and educated labor force (% of population) in Tertiary education in 2000 to that in 2001?
Provide a short and direct response. 1.02. What is the ratio of the Unemployed and educated labor force (% of population) of Primary education in 2000 to that in 2002?
Make the answer very short. 1.23. What is the ratio of the Unemployed and educated labor force (% of population) in Secondary education in 2000 to that in 2002?
Offer a very short reply. 0.96. What is the ratio of the Unemployed and educated labor force (% of population) in Tertiary education in 2000 to that in 2002?
Ensure brevity in your answer.  1.02. What is the ratio of the Unemployed and educated labor force (% of population) of Primary education in 2000 to that in 2003?
Provide a short and direct response. 1.34. What is the ratio of the Unemployed and educated labor force (% of population) of Secondary education in 2000 to that in 2003?
Offer a very short reply. 0.96. What is the ratio of the Unemployed and educated labor force (% of population) of Primary education in 2000 to that in 2004?
Keep it short and to the point. 0.64. What is the ratio of the Unemployed and educated labor force (% of population) of Secondary education in 2000 to that in 2004?
Ensure brevity in your answer.  1.07. What is the ratio of the Unemployed and educated labor force (% of population) of Tertiary education in 2000 to that in 2004?
Offer a terse response. 1.03. What is the ratio of the Unemployed and educated labor force (% of population) of Primary education in 2001 to that in 2002?
Give a very brief answer. 1.21. What is the ratio of the Unemployed and educated labor force (% of population) in Secondary education in 2001 to that in 2002?
Your answer should be compact. 0.98. What is the ratio of the Unemployed and educated labor force (% of population) in Tertiary education in 2001 to that in 2002?
Ensure brevity in your answer.  0.99. What is the ratio of the Unemployed and educated labor force (% of population) of Primary education in 2001 to that in 2003?
Provide a short and direct response. 1.33. What is the ratio of the Unemployed and educated labor force (% of population) in Secondary education in 2001 to that in 2003?
Your answer should be compact. 0.97. What is the ratio of the Unemployed and educated labor force (% of population) of Tertiary education in 2001 to that in 2003?
Provide a succinct answer. 0.98. What is the ratio of the Unemployed and educated labor force (% of population) of Primary education in 2001 to that in 2004?
Provide a succinct answer. 0.63. What is the ratio of the Unemployed and educated labor force (% of population) of Secondary education in 2001 to that in 2004?
Your answer should be compact. 1.08. What is the ratio of the Unemployed and educated labor force (% of population) in Tertiary education in 2001 to that in 2004?
Give a very brief answer. 1.01. What is the ratio of the Unemployed and educated labor force (% of population) of Primary education in 2002 to that in 2003?
Make the answer very short. 1.09. What is the ratio of the Unemployed and educated labor force (% of population) of Tertiary education in 2002 to that in 2003?
Ensure brevity in your answer.  0.99. What is the ratio of the Unemployed and educated labor force (% of population) in Primary education in 2002 to that in 2004?
Provide a short and direct response. 0.52. What is the ratio of the Unemployed and educated labor force (% of population) in Secondary education in 2002 to that in 2004?
Give a very brief answer. 1.11. What is the ratio of the Unemployed and educated labor force (% of population) in Tertiary education in 2002 to that in 2004?
Provide a short and direct response. 1.02. What is the ratio of the Unemployed and educated labor force (% of population) of Primary education in 2003 to that in 2004?
Your response must be concise. 0.47. What is the ratio of the Unemployed and educated labor force (% of population) in Secondary education in 2003 to that in 2004?
Give a very brief answer. 1.11. What is the ratio of the Unemployed and educated labor force (% of population) in Tertiary education in 2003 to that in 2004?
Your answer should be compact. 1.03. What is the difference between the highest and the second highest Unemployed and educated labor force (% of population) in Tertiary education?
Provide a succinct answer. 0.5. What is the difference between the highest and the lowest Unemployed and educated labor force (% of population) in Primary education?
Your answer should be very brief. 7.1. What is the difference between the highest and the lowest Unemployed and educated labor force (% of population) of Secondary education?
Provide a short and direct response. 32.6. What is the difference between the highest and the lowest Unemployed and educated labor force (% of population) of Tertiary education?
Make the answer very short. 29.5. 